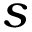<formula> <loc_0><loc_0><loc_500><loc_500>s</formula> 